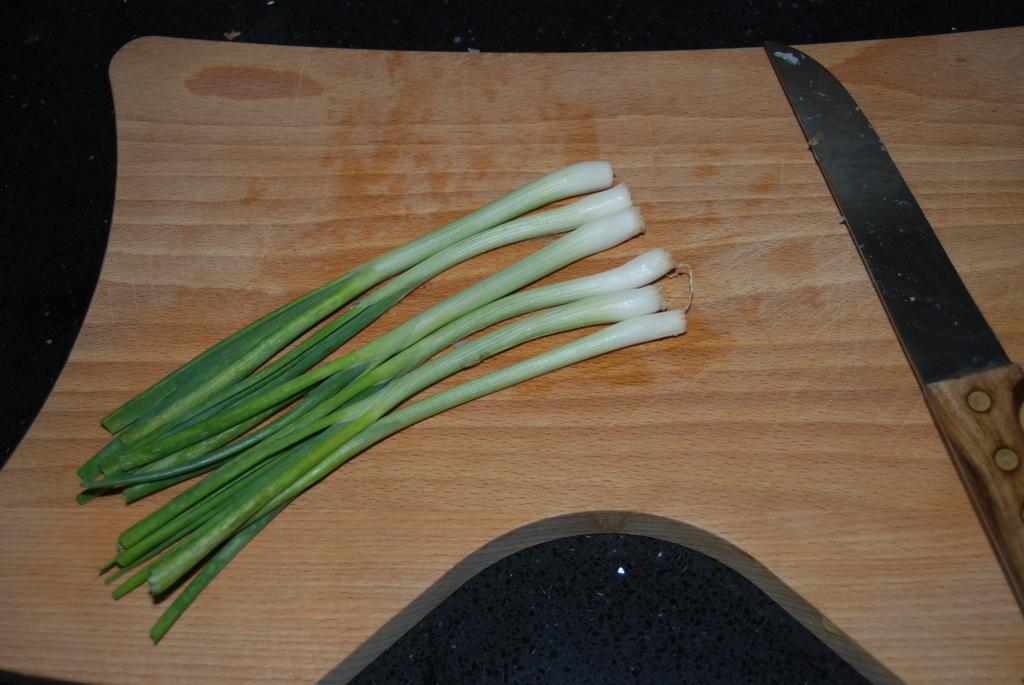What type of material is the plank in the image made of? The wooden plank in the image is made of wood. What type of vegetable is present in the image? There are spring onions in the image. What tool is visible in the image? There is a knife in the image. On what surface are the objects placed? The objects are placed on a platform. Can you tell me how many cans of beans are present in the image? There are no cans of beans present in the image. What type of doctor is attending to the cats in the image? There are no doctors or cats present in the image. 